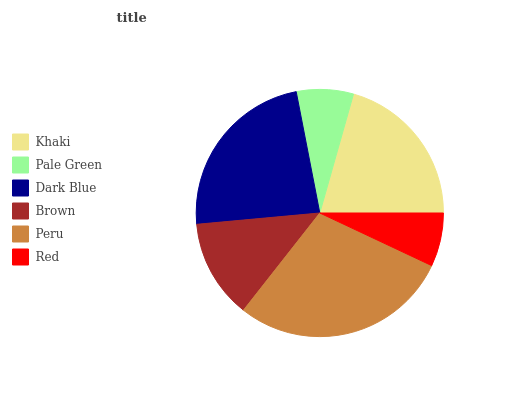Is Red the minimum?
Answer yes or no. Yes. Is Peru the maximum?
Answer yes or no. Yes. Is Pale Green the minimum?
Answer yes or no. No. Is Pale Green the maximum?
Answer yes or no. No. Is Khaki greater than Pale Green?
Answer yes or no. Yes. Is Pale Green less than Khaki?
Answer yes or no. Yes. Is Pale Green greater than Khaki?
Answer yes or no. No. Is Khaki less than Pale Green?
Answer yes or no. No. Is Khaki the high median?
Answer yes or no. Yes. Is Brown the low median?
Answer yes or no. Yes. Is Dark Blue the high median?
Answer yes or no. No. Is Dark Blue the low median?
Answer yes or no. No. 